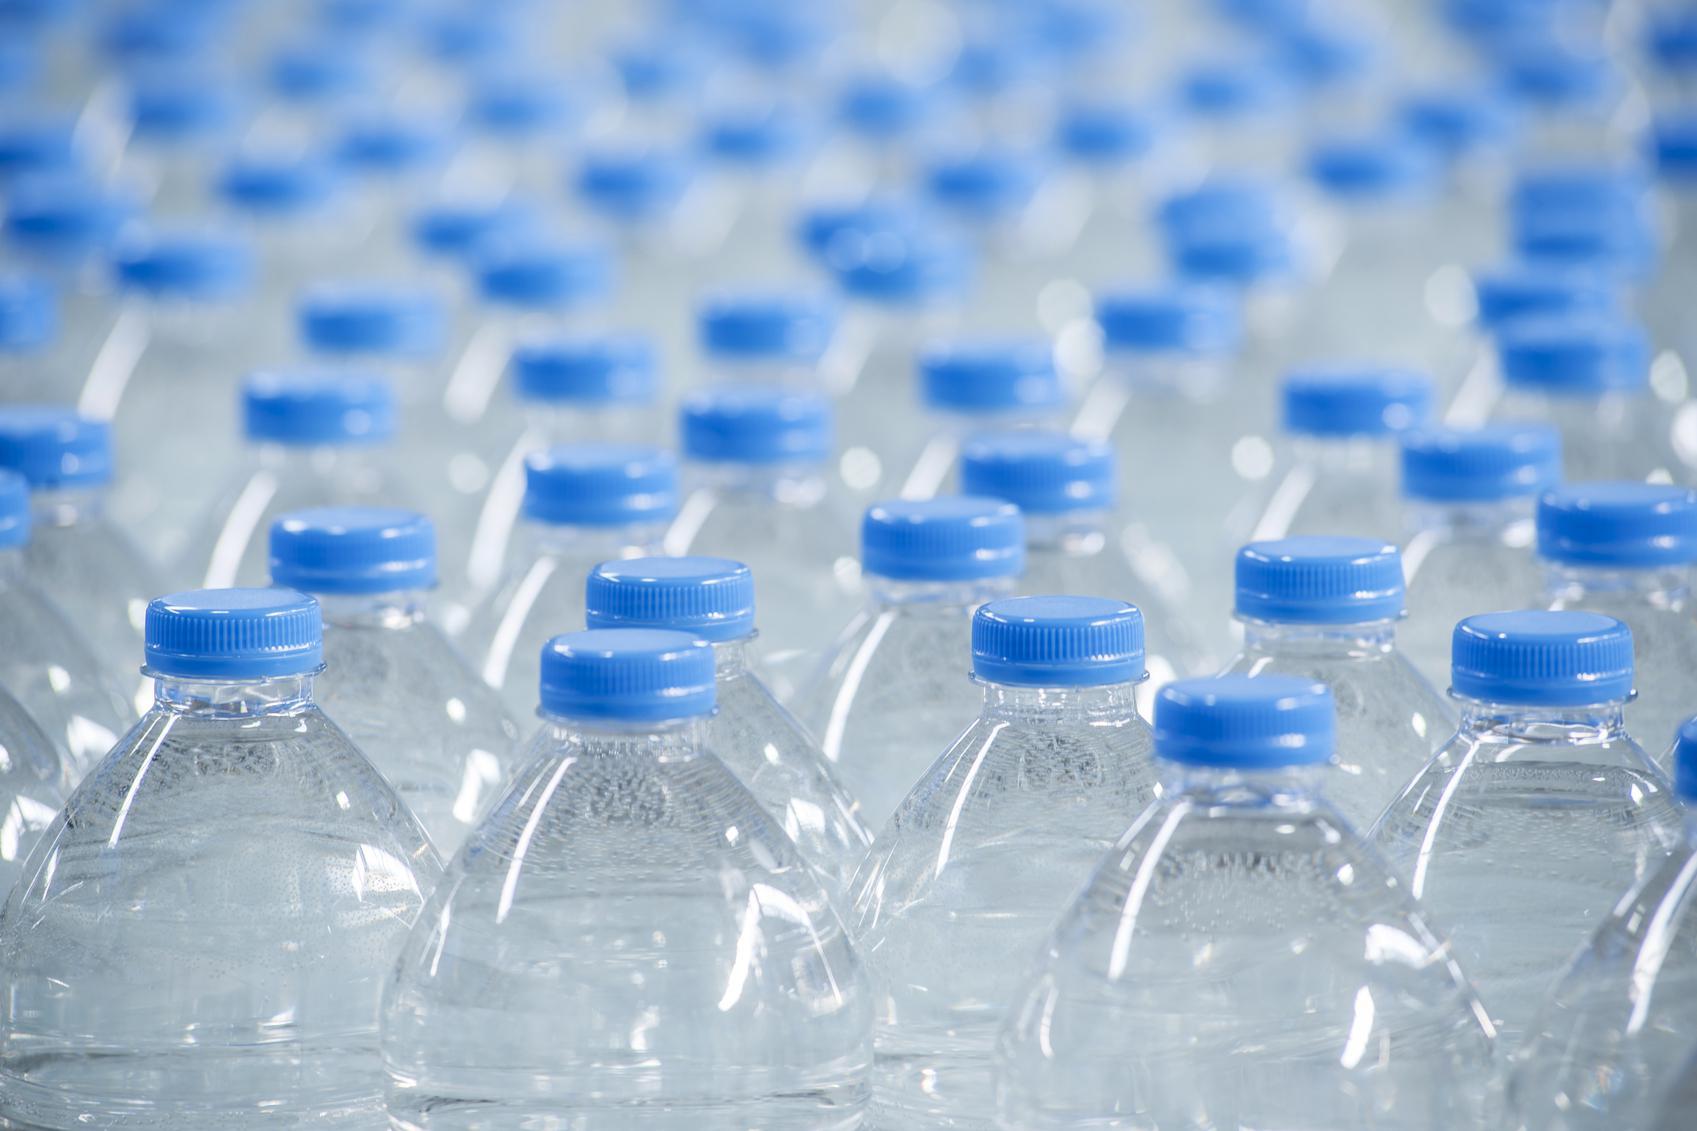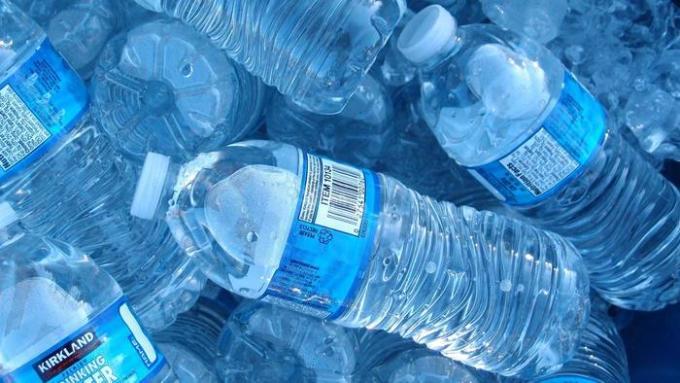The first image is the image on the left, the second image is the image on the right. Examine the images to the left and right. Is the description "the white capped bottles in the image on the right are sealed in packages of at least 16" accurate? Answer yes or no. No. The first image is the image on the left, the second image is the image on the right. Analyze the images presented: Is the assertion "At least one image shows stacked plastic-wrapped bundles of bottles." valid? Answer yes or no. No. 